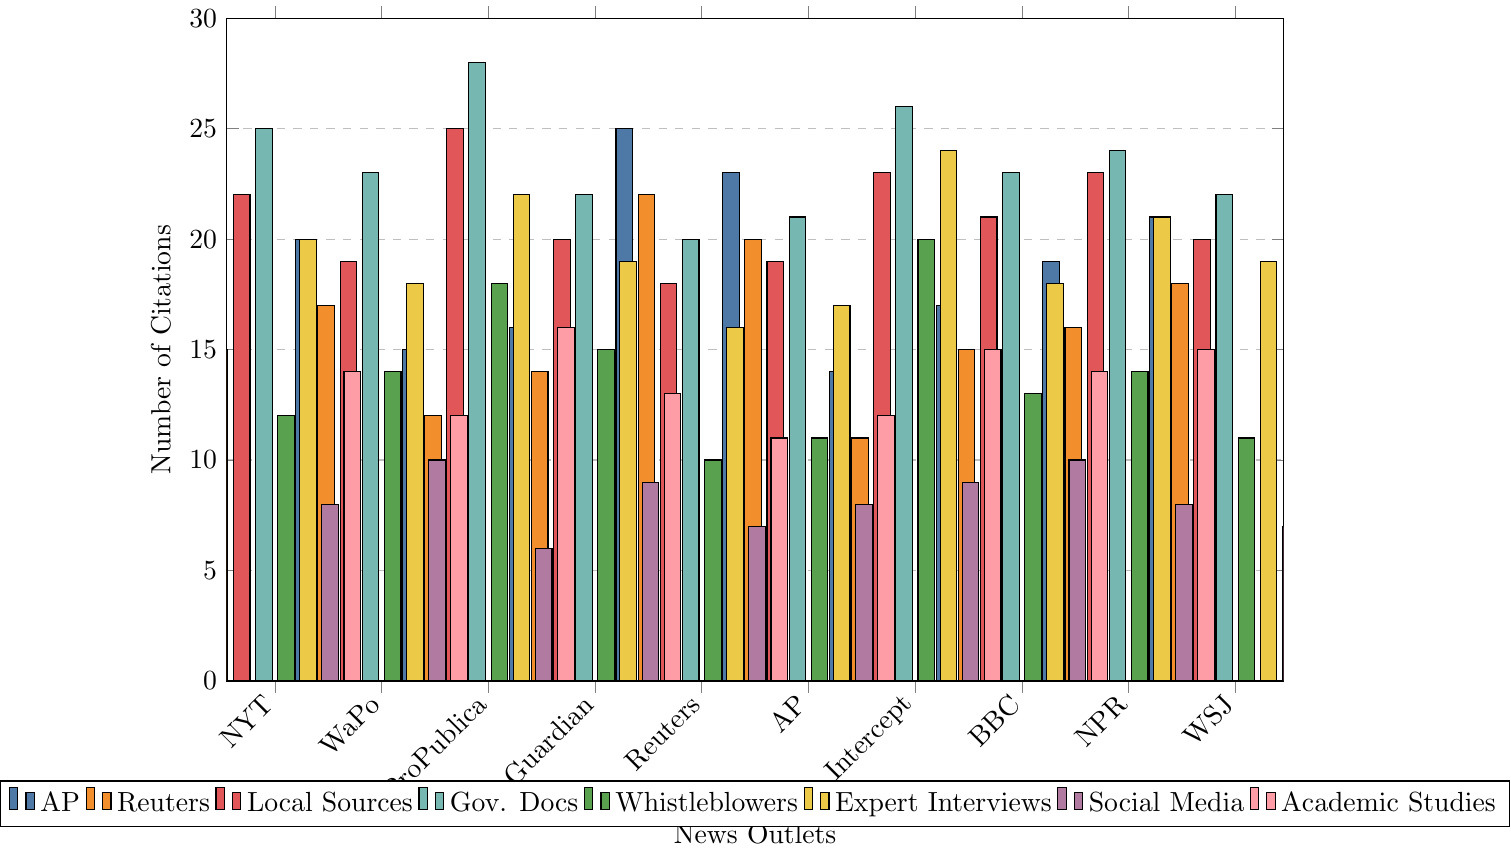Which news outlet cites whistleblowers the most? To find the news outlet that cites whistleblowers the most, look for the tallest bar that represents the citations of whistleblowers (fifth set of bars, green color). "The Intercept" has the highest bar with 20 citations from whistleblowers.
Answer: The Intercept Which news outlet relies the most on local sources? Examine the third set of bars (red color), which represents local sources citations. The tallest bar belongs to ProPublica, with 25 citations from local sources.
Answer: ProPublica How does "The New York Times" compare to "ProPublica" in terms of the use of government documents? Look at the fourth set of bars (blue color) to compare both news outlets for government document citations. "The New York Times" has 25 citations, while "ProPublica" has a higher count with 28 citations.
Answer: ProPublica cites more What is the total number of social media citations for "NPR" and "BBC News" combined? Identify the seventh set of bars (cyan color) for social media citations. NPR has 8 citations and BBC News has 10 citations. Adding them together: 8 + 10 = 18.
Answer: 18 Which news outlet has the lowest number of AP citations? Look at the first set of bars (dark blue color). "The Intercept" has the lowest count with 14 AP citations.
Answer: The Intercept What is the average number of academic studies cited by "Reuters" and "Associated Press"? Check the eighth set of bars (pink color) for citations. "Reuters" has 11 academic studies, and "AP" has 12. The average is (11 + 12) / 2 = 11.5.
Answer: 11.5 Which news outlet has the exact same number of expert interviews as government documents? Identify the bars for expert interviews (yellow color) and government documents (blue color). "BBC News" has 18 for both categories.
Answer: BBC News How many more local sources does "The Guardian" cite compared to "Reuters"? Look at the third set of bars (red color). "The Guardian" cites 20 local sources, whereas "Reuters" cites 18. The difference is 20 - 18 = 2.
Answer: 2 What is the highest number of social media citations among all news outlets? Refer to the seventh set of bars (cyan color). The highest bar is at 10 citations.
Answer: 10 